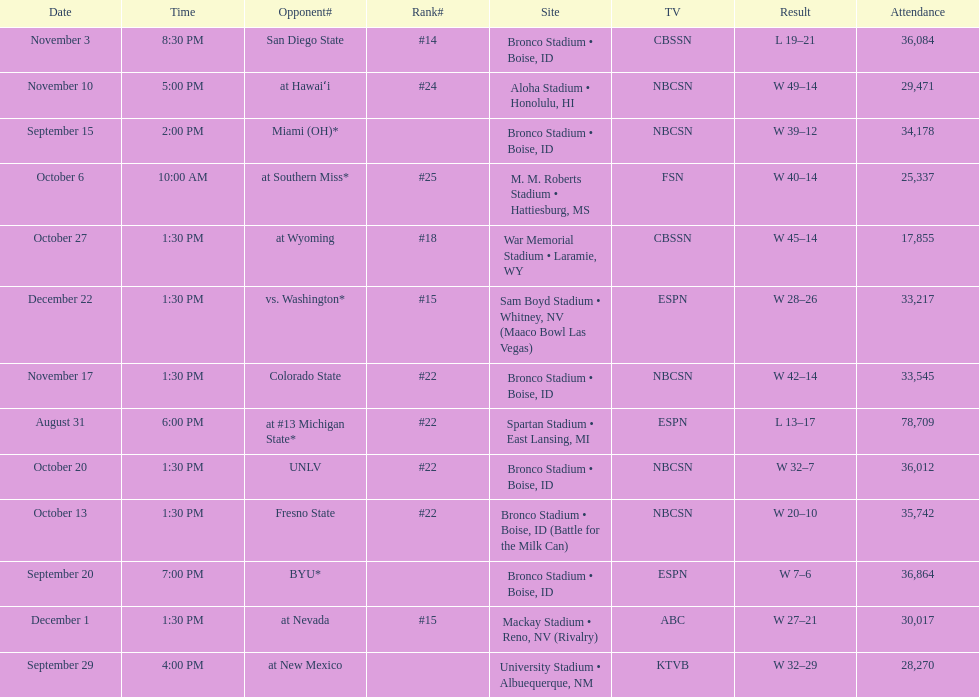What was their highest-ranked position of the season? #14. 